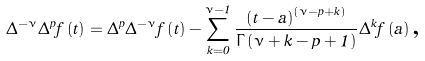<formula> <loc_0><loc_0><loc_500><loc_500>\Delta ^ { - \nu } \Delta ^ { p } f \left ( t \right ) = \Delta ^ { p } \Delta ^ { - \nu } f \left ( t \right ) - \sum _ { k = 0 } ^ { \nu - 1 } \frac { \left ( t - a \right ) ^ { \left ( \nu - p + k \right ) } } { \Gamma \left ( \nu + k - p + 1 \right ) } \Delta ^ { k } f \left ( a \right ) \text {,}</formula> 